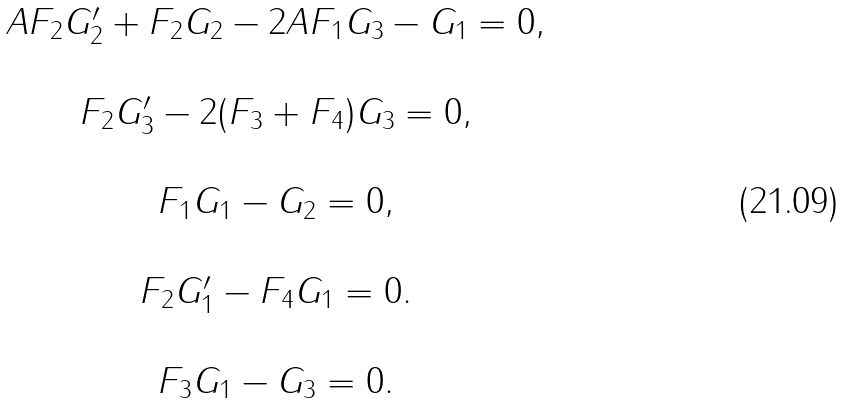<formula> <loc_0><loc_0><loc_500><loc_500>\begin{array} { c } A F _ { 2 } G _ { 2 } ^ { \prime } + F _ { 2 } G _ { 2 } - 2 A F _ { 1 } G _ { 3 } - G _ { 1 } = 0 , \\ \\ F _ { 2 } G _ { 3 } ^ { \prime } - 2 ( F _ { 3 } + F _ { 4 } ) G _ { 3 } = 0 , \\ \\ F _ { 1 } G _ { 1 } - G _ { 2 } = 0 , \\ \\ F _ { 2 } G _ { 1 } ^ { \prime } - F _ { 4 } G _ { 1 } = 0 . \\ \\ F _ { 3 } G _ { 1 } - G _ { 3 } = 0 . \\ \end{array}</formula> 